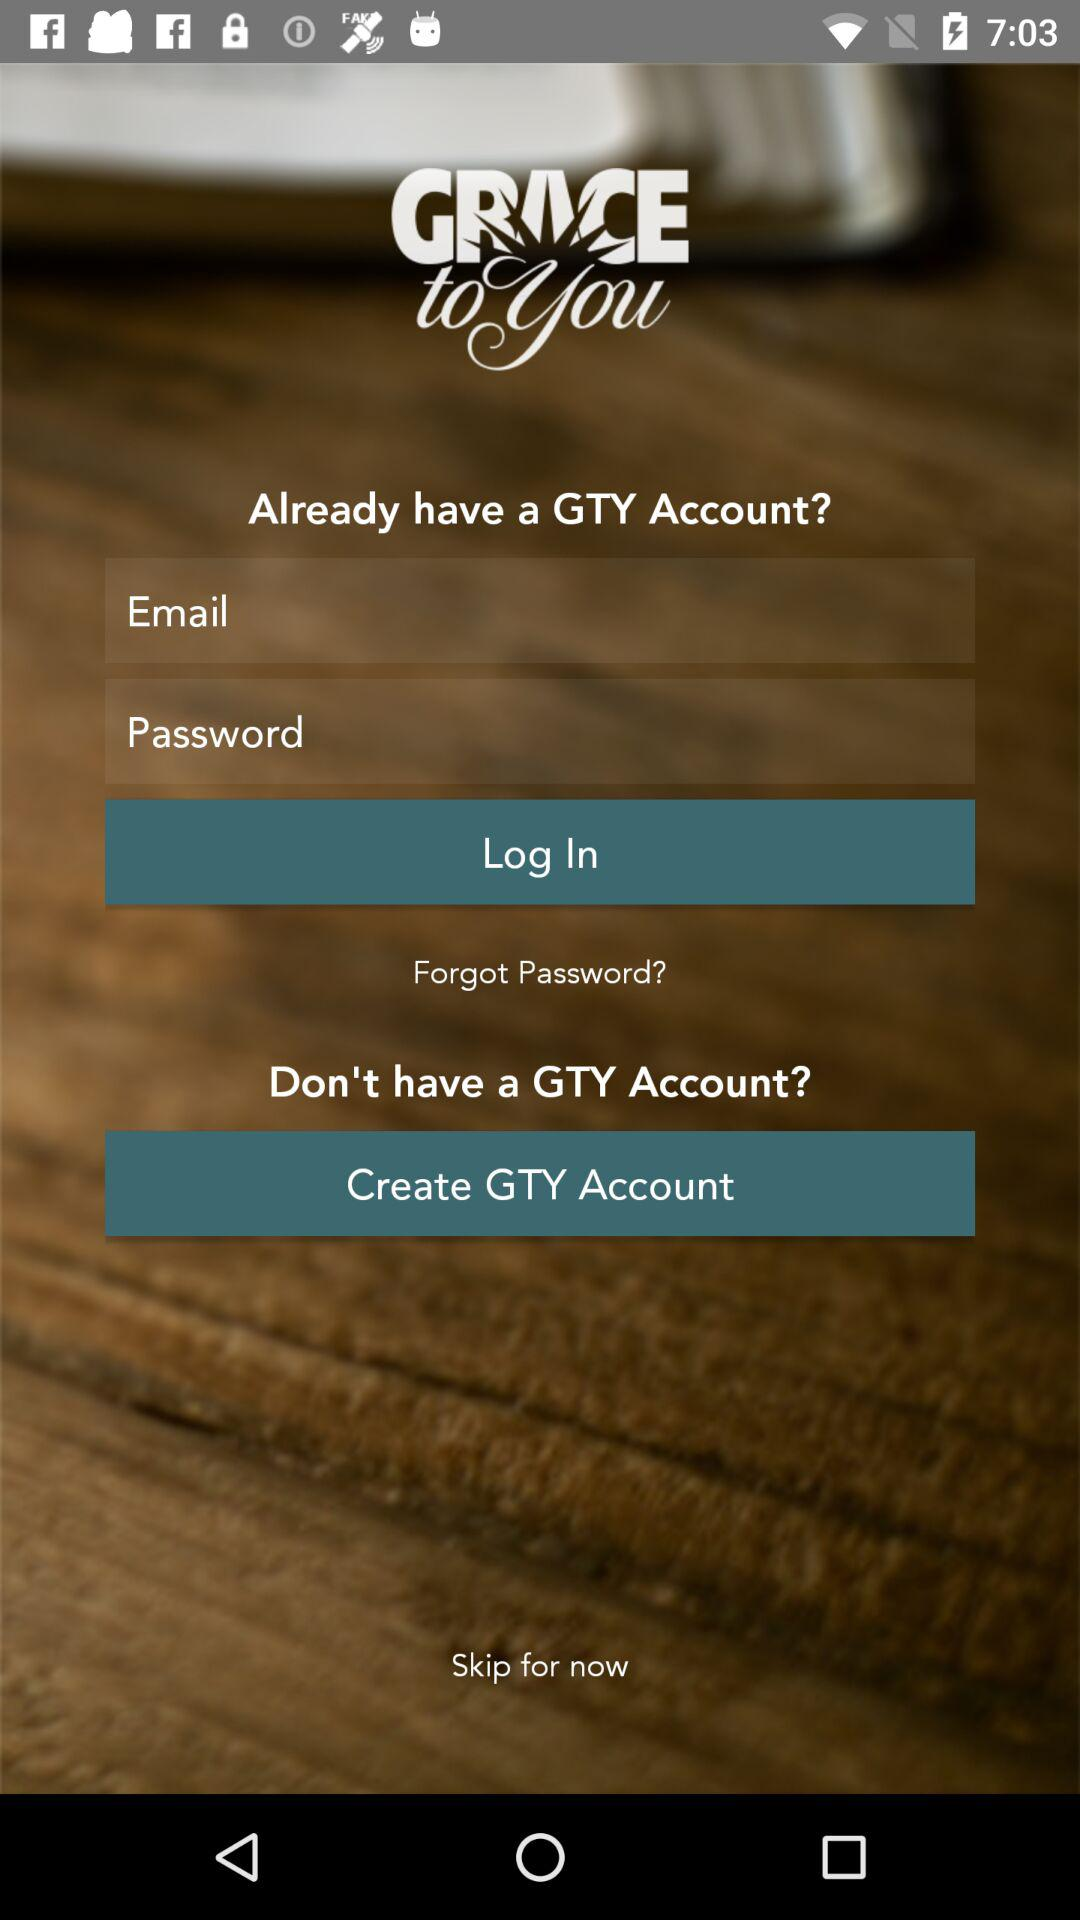Can we reset password?
When the provided information is insufficient, respond with <no answer>. <no answer> 